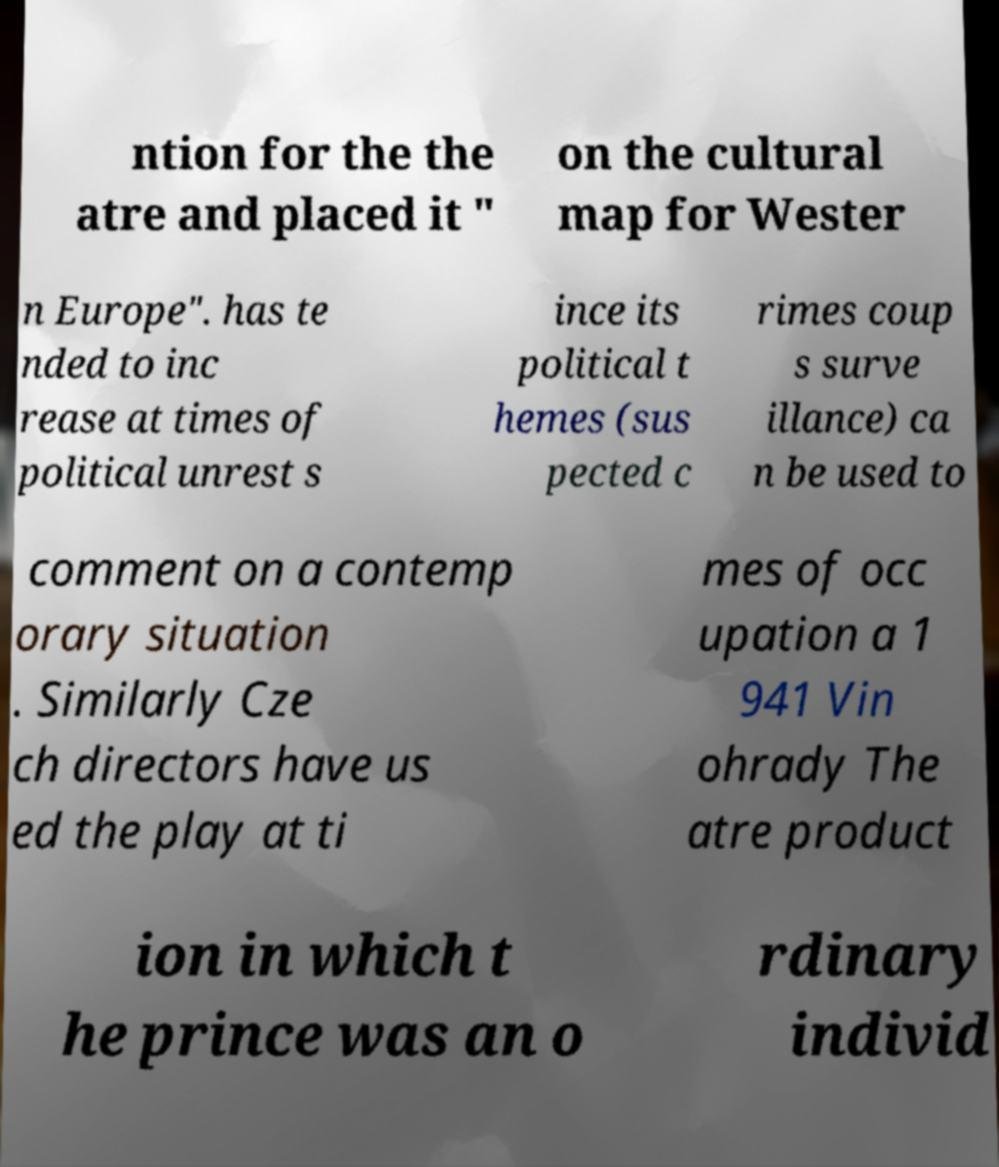Could you extract and type out the text from this image? ntion for the the atre and placed it " on the cultural map for Wester n Europe". has te nded to inc rease at times of political unrest s ince its political t hemes (sus pected c rimes coup s surve illance) ca n be used to comment on a contemp orary situation . Similarly Cze ch directors have us ed the play at ti mes of occ upation a 1 941 Vin ohrady The atre product ion in which t he prince was an o rdinary individ 